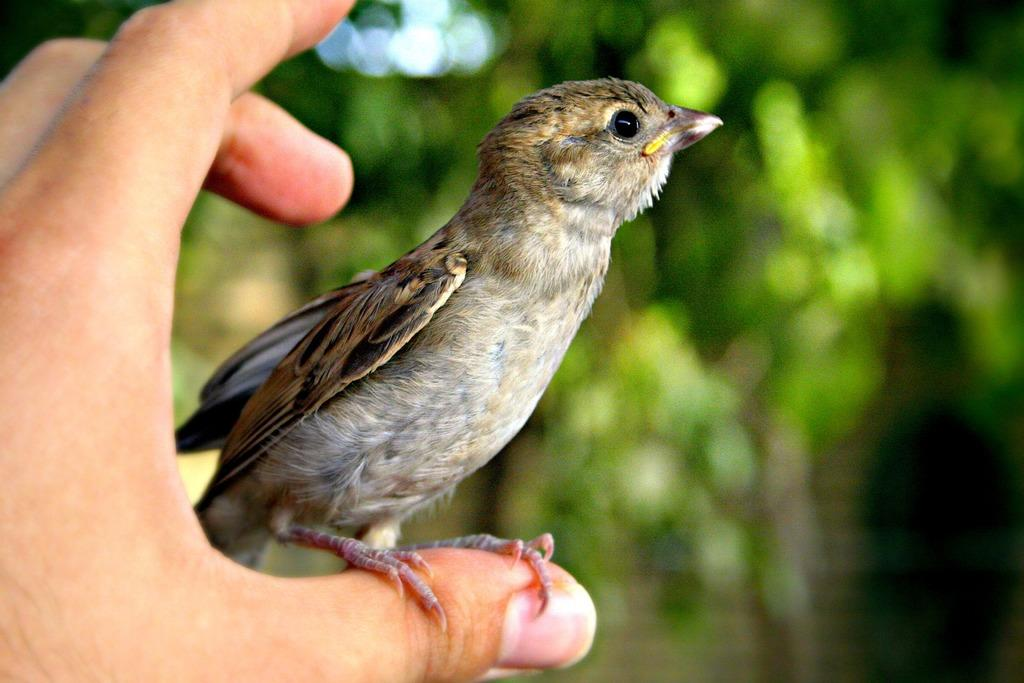What is happening in the left corner of the image? There is a human hand holding a bird in the left corner of the image. What can be seen in the background of the image? There are trees in the background of the image. How would you describe the background of the image? The background is blurred. What type of growth can be seen on the collar of the bird in the image? There is no collar on the bird in the image, and therefore no growth can be observed on it. 